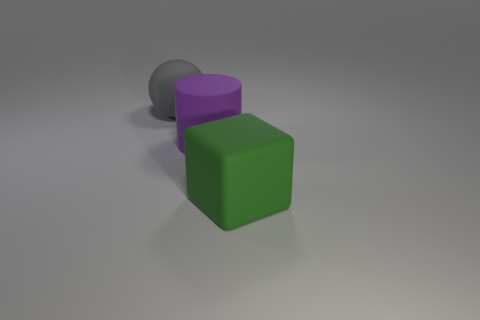Add 1 large yellow shiny balls. How many objects exist? 4 Subtract all balls. How many objects are left? 2 Add 2 big spheres. How many big spheres exist? 3 Subtract 0 cyan balls. How many objects are left? 3 Subtract all green rubber objects. Subtract all purple matte cylinders. How many objects are left? 1 Add 1 gray rubber spheres. How many gray rubber spheres are left? 2 